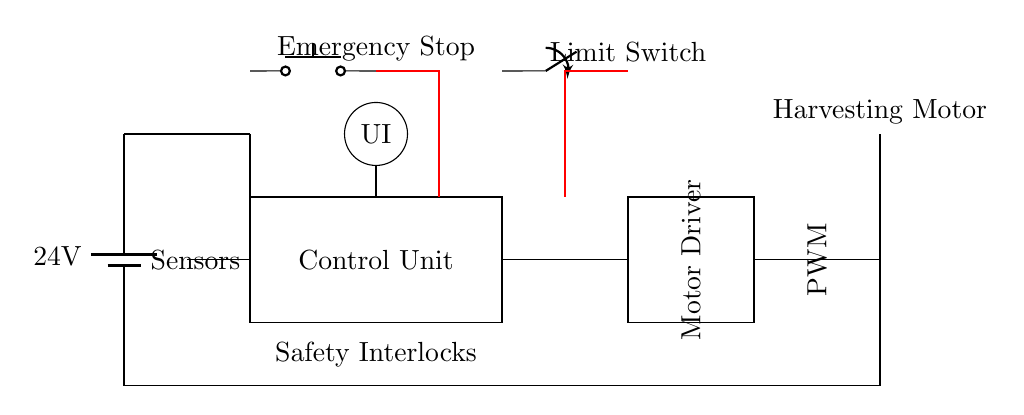What is the voltage of the power supply? The voltage of the power supply is indicated on the battery symbol in the circuit diagram, which shows a potential of 24 volts.
Answer: 24 volts What component controls the motor operation? The Motor Driver is the component responsible for controlling the operation of the Harvesting Motor, as indicated in its label in the circuit diagram.
Answer: Motor Driver What does the red thick line represent? The red thick lines represent safety interlock connections that prevent the motor operation unless safe conditions are met, as seen connecting the Emergency Stop and Limit Switch to the Control Unit.
Answer: Safety interlocks How many input sensors are indicated? One sensor input is shown leading into the Control Unit, as marked in the circuit diagram, hence there is only one sensor input.
Answer: One What action does the Emergency Stop button perform? The Emergency Stop button serves as a safety mechanism to cut off power to the motor, which is represented by its position and connection in the circuit diagram, ensuring immediate cessation of operations.
Answer: Cuts off power Where is the user interface located in the circuit? The User Interface is indicated with a circle in the circuit diagram, located at the coordinates provided, directly above the control unit portion of the circuit.
Answer: Above the control unit 